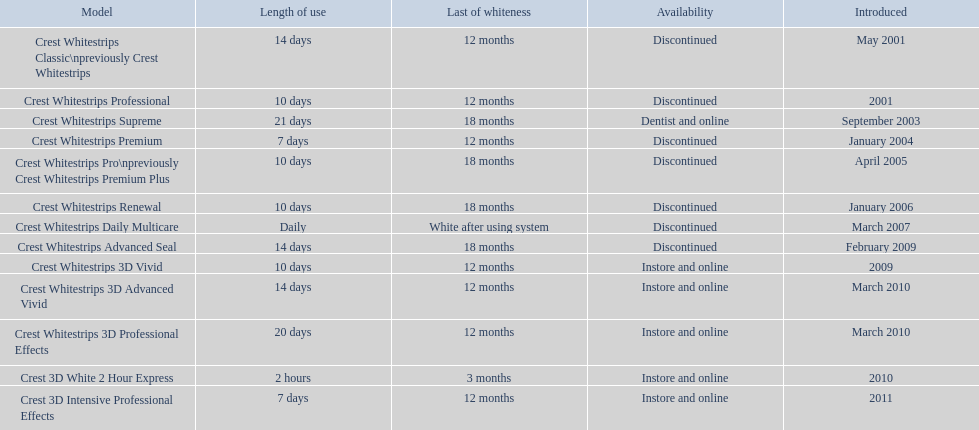What were the models of crest whitestrips? Crest Whitestrips Classic\npreviously Crest Whitestrips, Crest Whitestrips Professional, Crest Whitestrips Supreme, Crest Whitestrips Premium, Crest Whitestrips Pro\npreviously Crest Whitestrips Premium Plus, Crest Whitestrips Renewal, Crest Whitestrips Daily Multicare, Crest Whitestrips Advanced Seal, Crest Whitestrips 3D Vivid, Crest Whitestrips 3D Advanced Vivid, Crest Whitestrips 3D Professional Effects, Crest 3D White 2 Hour Express, Crest 3D Intensive Professional Effects. When were they introduced? May 2001, 2001, September 2003, January 2004, April 2005, January 2006, March 2007, February 2009, 2009, March 2010, March 2010, 2010, 2011. And what is their availability? Discontinued, Discontinued, Dentist and online, Discontinued, Discontinued, Discontinued, Discontinued, Discontinued, Instore and online, Instore and online, Instore and online, Instore and online, Instore and online. Along crest whitestrips 3d vivid, which discontinued model was released in 2009? Crest Whitestrips Advanced Seal. 